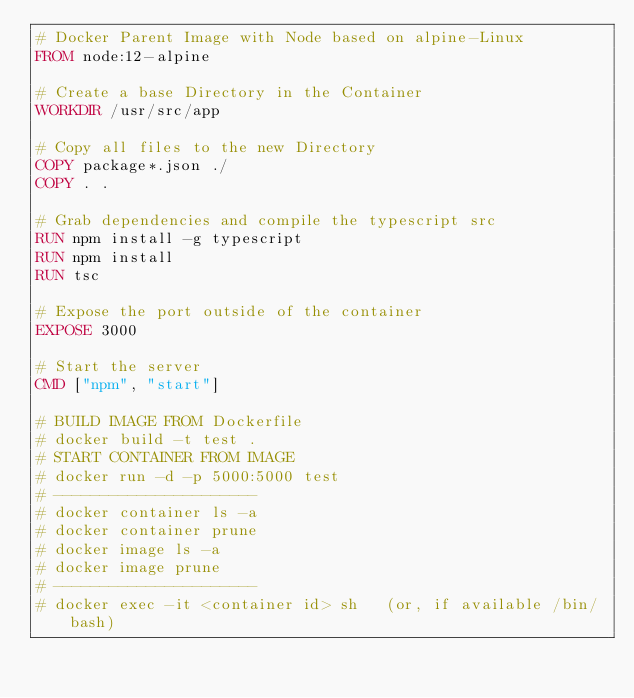Convert code to text. <code><loc_0><loc_0><loc_500><loc_500><_Dockerfile_># Docker Parent Image with Node based on alpine-Linux
FROM node:12-alpine

# Create a base Directory in the Container
WORKDIR /usr/src/app

# Copy all files to the new Directory
COPY package*.json ./
COPY . .

# Grab dependencies and compile the typescript src
RUN npm install -g typescript
RUN npm install
RUN tsc

# Expose the port outside of the container
EXPOSE 3000

# Start the server
CMD ["npm", "start"]

# BUILD IMAGE FROM Dockerfile
# docker build -t test .
# START CONTAINER FROM IMAGE
# docker run -d -p 5000:5000 test
# ----------------------
# docker container ls -a
# docker container prune
# docker image ls -a
# docker image prune
# ----------------------
# docker exec -it <container id> sh   (or, if available /bin/bash)
</code> 